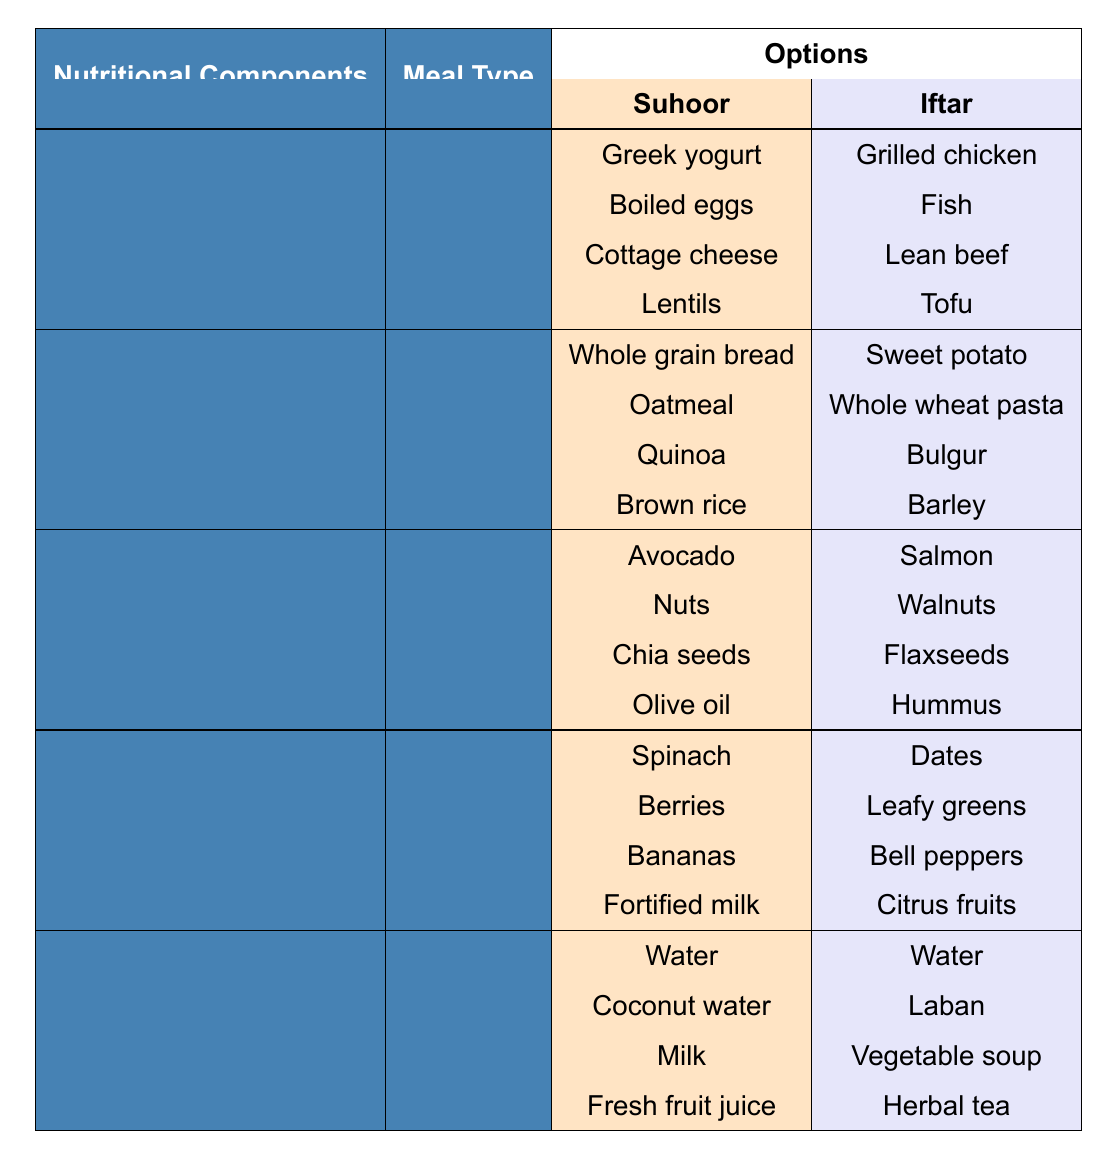What meal type has more options under the hydration component? The hydration component for Suhoor has four options: Water, Coconut water, Milk, and Fresh fruit juice. The hydration component for Iftar also has four options: Water, Laban, Vegetable soup, and Herbal tea. Both meal types have the same number of options.
Answer: Both meals have equal options Which vitamin options are available for Suhoor? The vitamin options for Suhoor are Spinach, Berries, Bananas, and Fortified milk. These options can be found in the table under the Vitamins section for the Suhoor meal.
Answer: Spinach, Berries, Bananas, Fortified milk Is there an option for healthy fats in the Iftar meal? Yes, there are several options for healthy fats in the Iftar meal: Salmon, Walnuts, Flaxseeds, and Hummus can be found under the Healthy Fats component.
Answer: Yes Which meal type includes both grilled chicken and sweet potato options? Grilled chicken is listed as an option for Iftar under the Protein component, while Sweet potato is listed under the Complex Carbs component for Iftar. Only Iftar includes both options.
Answer: Iftar meal If I choose to have walnuts and dates, what meal type am I consuming? Walnuts are listed under the Healthy Fats component for Iftar, and Dates are listed under the Vitamins component for Iftar. Therefore, consuming both means you are having Iftar.
Answer: Iftar How many protein options are available in total when combining Suhoor and Iftar meals? Suhoor has four protein options (Greek yogurt, Boiled eggs, Cottage cheese, Lentils) and Iftar has four protein options (Grilled chicken, Fish, Lean beef, Tofu). Adding these together gives a total of 8 protein options.
Answer: 8 protein options Which meal type has more options for complex carbs? The table shows that both Suhoor and Iftar have four options for complex carbs. Suhoor has Whole grain bread, Oatmeal, Quinoa, and Brown rice, whereas Iftar has Sweet potato, Whole wheat pasta, Bulgur, and Barley. Therefore, neither meal type has more options.
Answer: Both have equal options Can I find an option for lentils in Iftar? Lentils are listed as an option under the Protein component for Suhoor only. There are no lentil options listed under the Iftar meal.
Answer: No What are the hydration options available if I choose Suhoor? The hydration options for Suhoor are Water, Coconut water, Milk, and Fresh fruit juice, as listed in the hydration section for Suhoor.
Answer: Water, Coconut water, Milk, Fresh fruit juice If I want to consume a meal with healthy fats and vitamins, which options should I choose? For Suhoor, you can choose Avocado (healthy fat) and any of the vitamin options like Spinach, Berries, Bananas, or Fortified milk. For Iftar, you could choose Salmon or Hummus (healthy fats) along with Dates, Leafy greens, Bell peppers, or Citrus fruits (vitamins). This gives you flexibility in both meal types.
Answer: Suhoor or Iftar options 